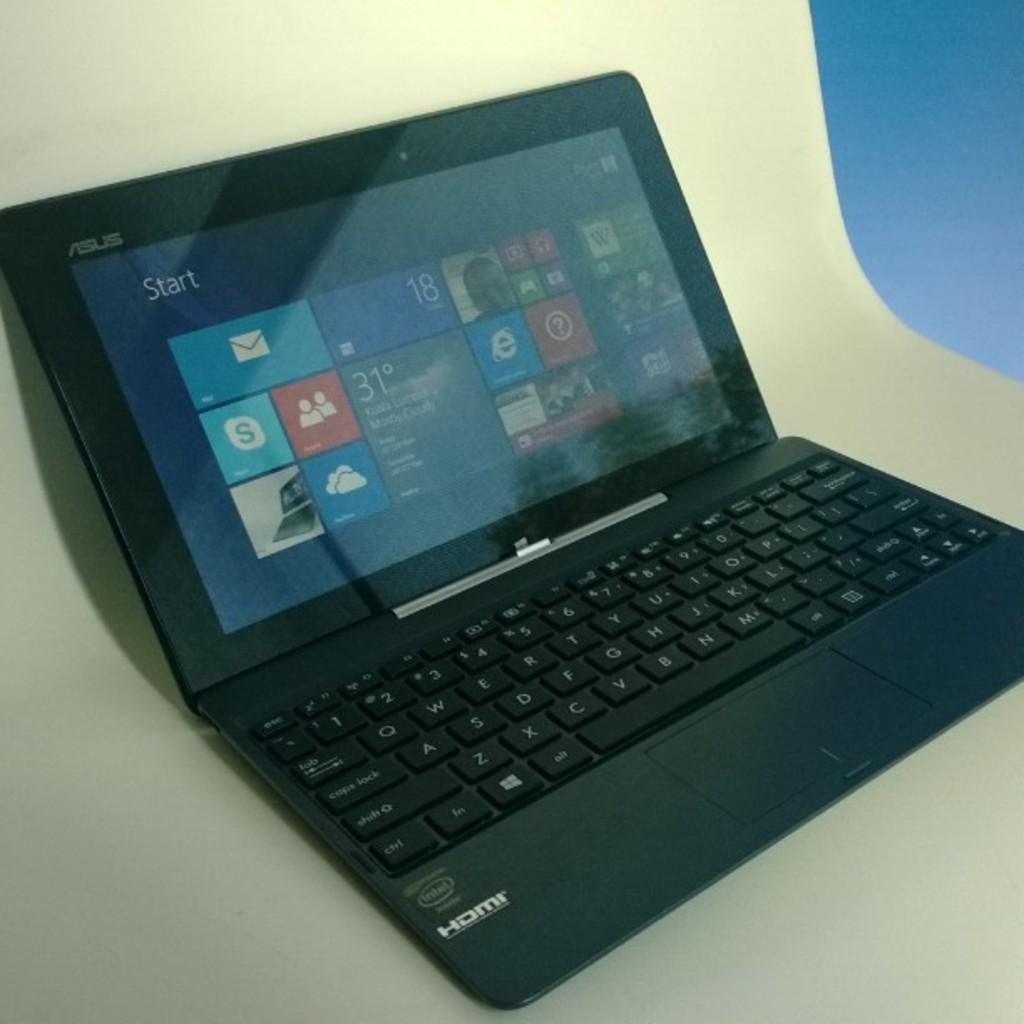What electronic device is visible in the image? There is a laptop in the image. What might the laptop be used for? The laptop could be used for various tasks, such as browsing the internet, working on documents, or streaming media. What type of oatmeal is being prepared on the laptop in the image? There is no oatmeal present in the image, nor is it being prepared on the laptop. 